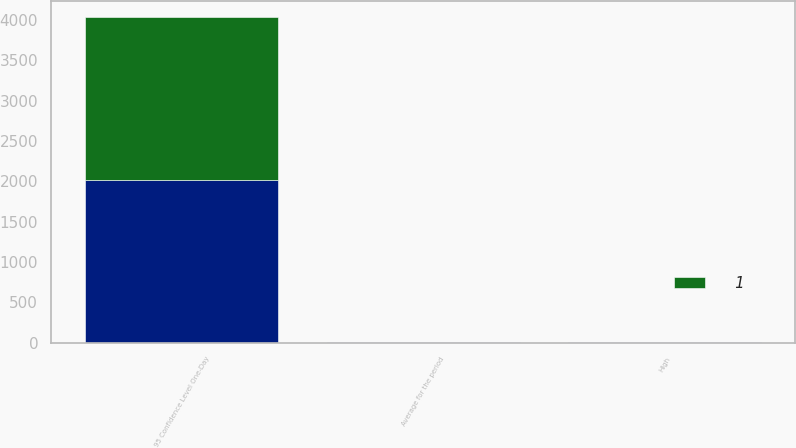Convert chart to OTSL. <chart><loc_0><loc_0><loc_500><loc_500><stacked_bar_chart><ecel><fcel>95 Confidence Level One-Day<fcel>Average for the period<fcel>High<nl><fcel>nan<fcel>2016<fcel>2<fcel>4<nl><fcel>1<fcel>2015<fcel>1<fcel>2<nl></chart> 